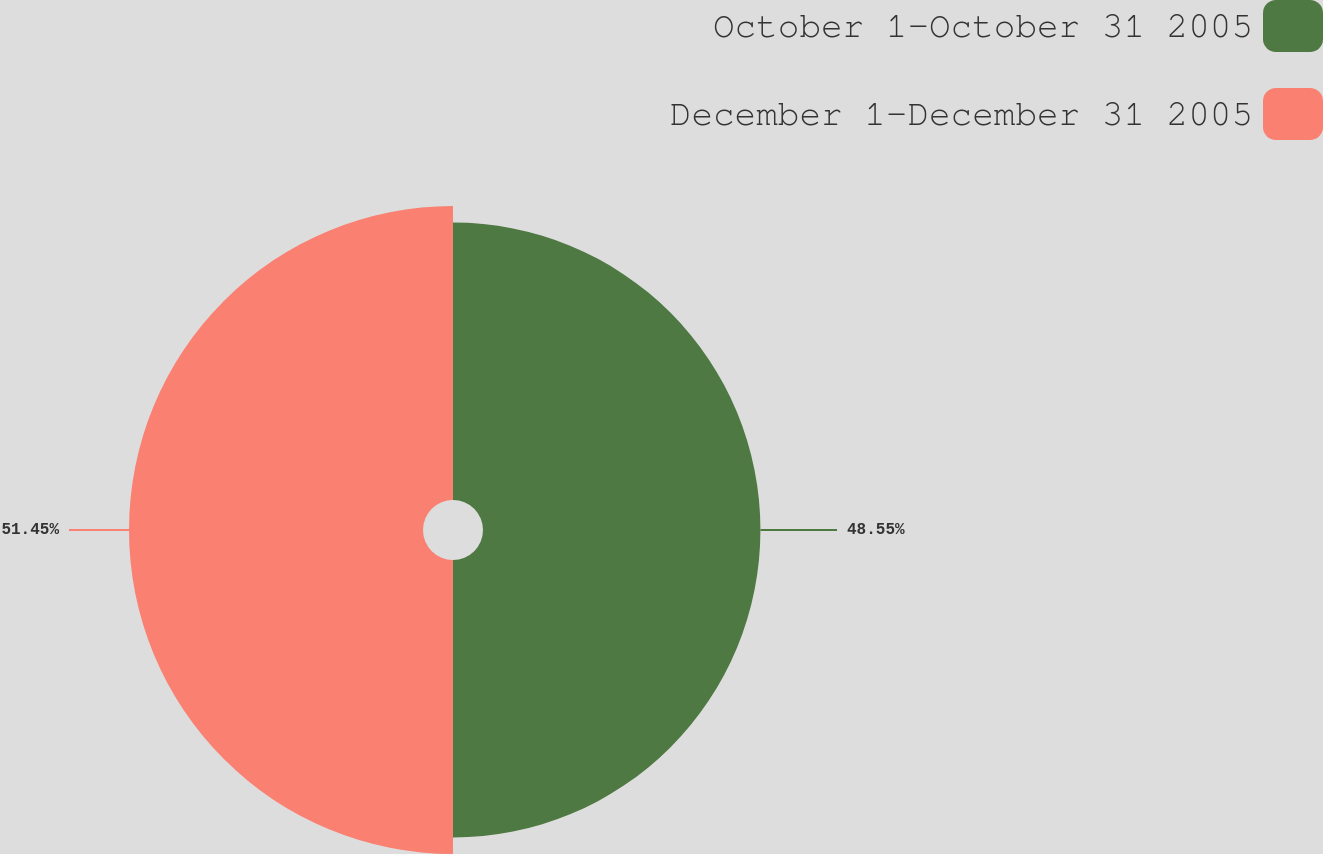<chart> <loc_0><loc_0><loc_500><loc_500><pie_chart><fcel>October 1-October 31 2005<fcel>December 1-December 31 2005<nl><fcel>48.55%<fcel>51.45%<nl></chart> 